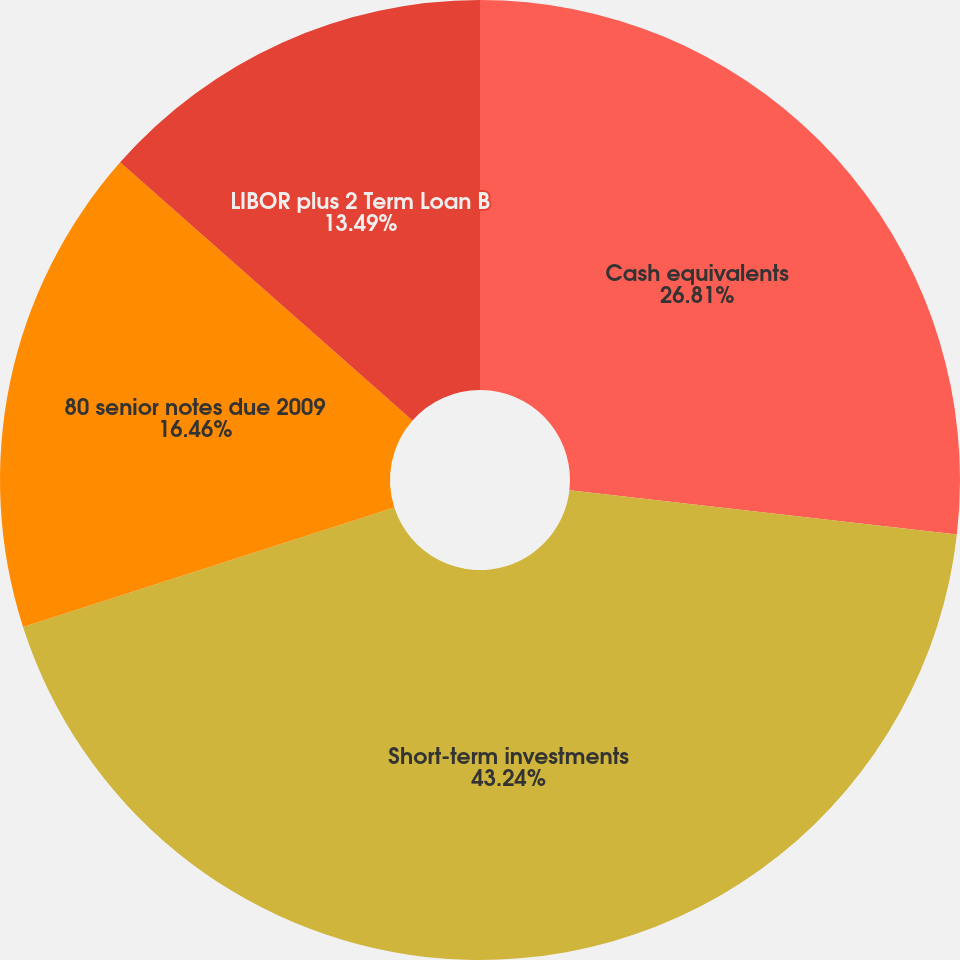<chart> <loc_0><loc_0><loc_500><loc_500><pie_chart><fcel>Cash equivalents<fcel>Short-term investments<fcel>80 senior notes due 2009<fcel>LIBOR plus 2 Term Loan B<nl><fcel>26.81%<fcel>43.24%<fcel>16.46%<fcel>13.49%<nl></chart> 